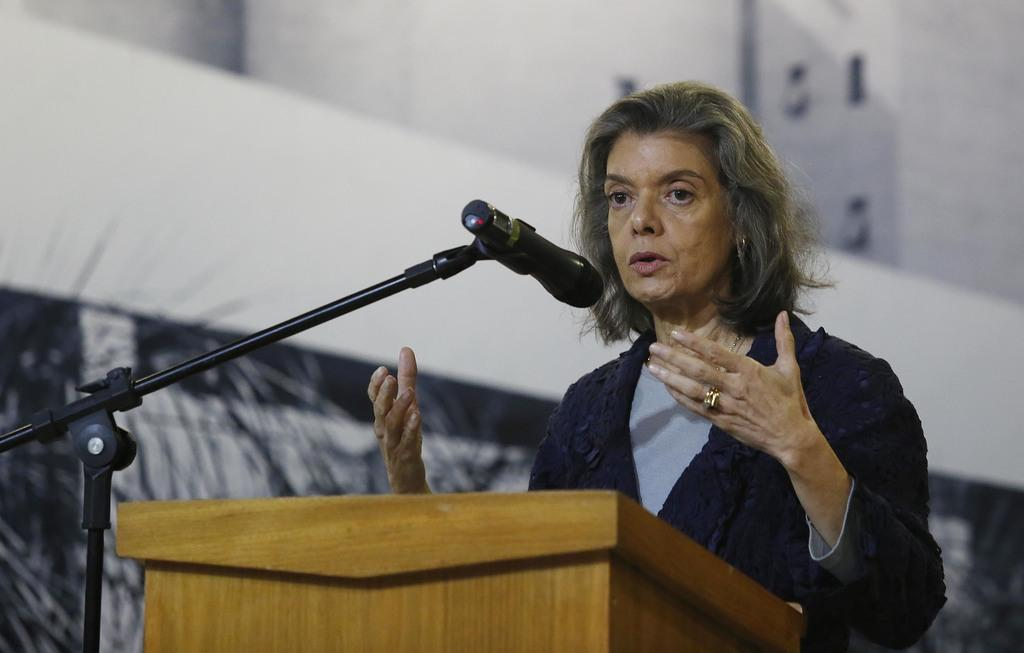Who is the main subject in the picture? There is a woman in the picture. What is the woman standing in front of? The woman is standing in front of a wooden podium. What is the woman doing in the picture? The woman is speaking on a microphone. What type of pets can be seen in the picture? There are no pets visible in the picture. Can you describe the weather conditions in the image? The provided facts do not mention any weather conditions, so it cannot be determined from the image. 